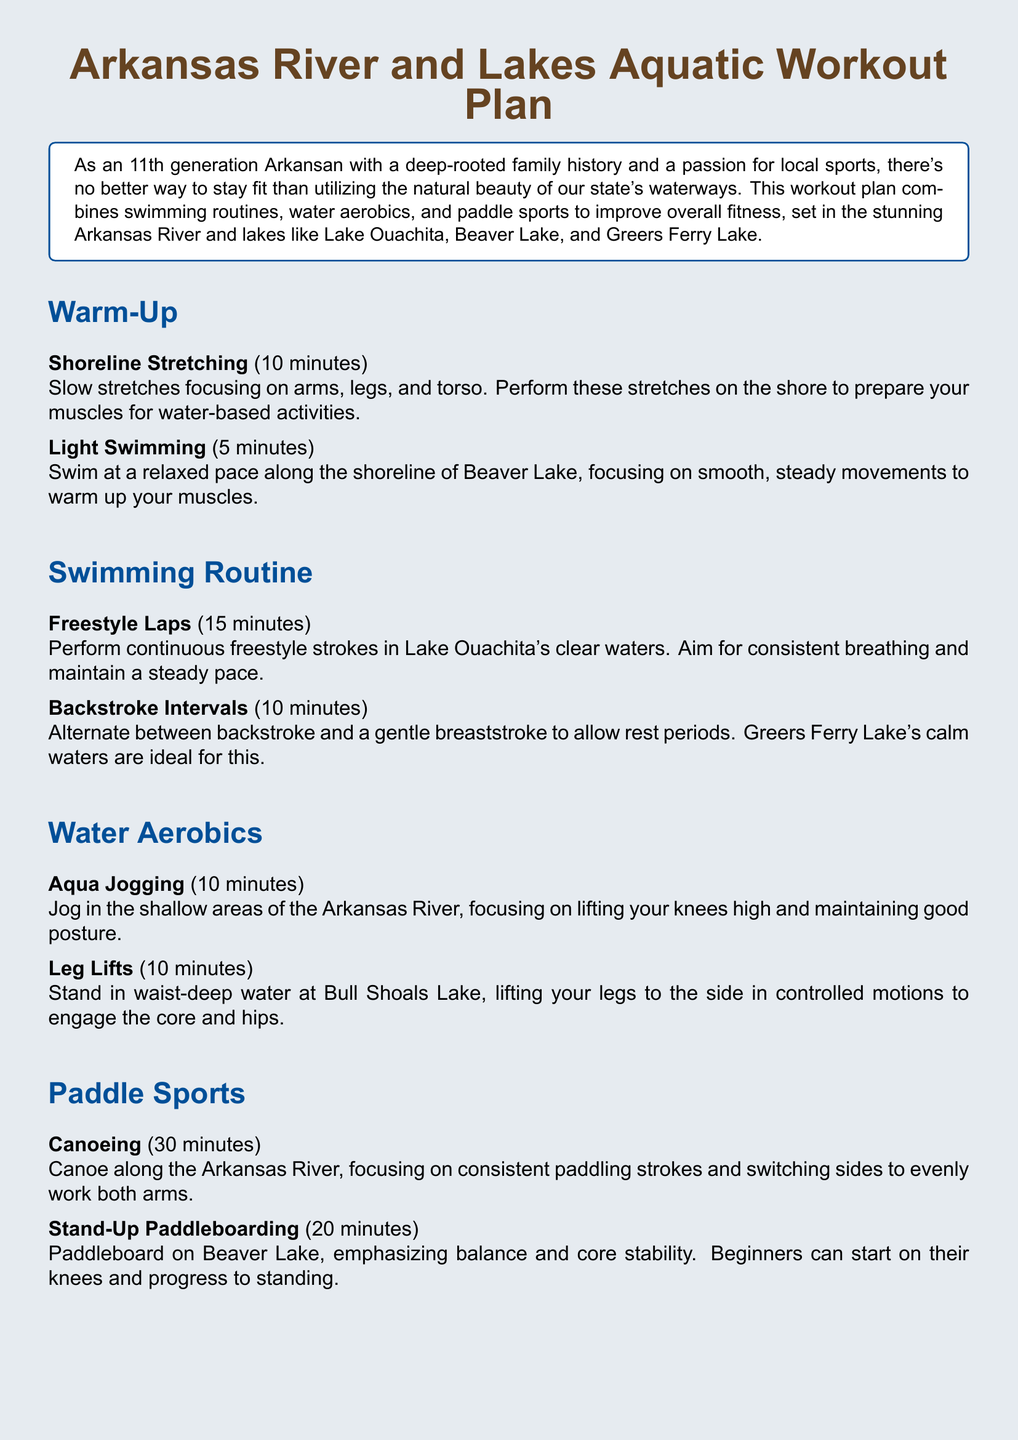What is the title of the workout plan? The title is presented prominently at the top of the document, indicating the focus on aquatic workouts in Arkansas waterways.
Answer: Arkansas River and Lakes Aquatic Workout Plan How long is the freestyle laps activity? The duration of the freestyle laps is explicitly stated in the document, focusing on swimming in Lake Ouachita.
Answer: 15 minutes What activity is performed for cooling down? The document lists specific activities for cooling down, indicating the importance of gradual heart rate reduction.
Answer: Gentle Swimming What is the total time allocated for shoreline stretching? The document specifies the time for shoreline stretching in both warm-up and cool down sections, allowing for easy calculation.
Answer: 20 minutes What type of water is ideal for backstroke intervals? The document mentions the ideal conditions for performing backstroke intervals, guiding users to the appropriate lake.
Answer: Greers Ferry Lake What muscle groups do leg lifts engage? The document discusses the target muscle groups for the leg lifts activity performed at Bull Shoals Lake.
Answer: Core and hips How long should the canoeing activity be performed? The document clearly indicates the duration for the canoeing activity on the Arkansas River.
Answer: 30 minutes What is emphasized during stand-up paddleboarding? The document emphasizes a specific skill to be developed during paddleboarding, helping users focus on their technique.
Answer: Balance and core stability 